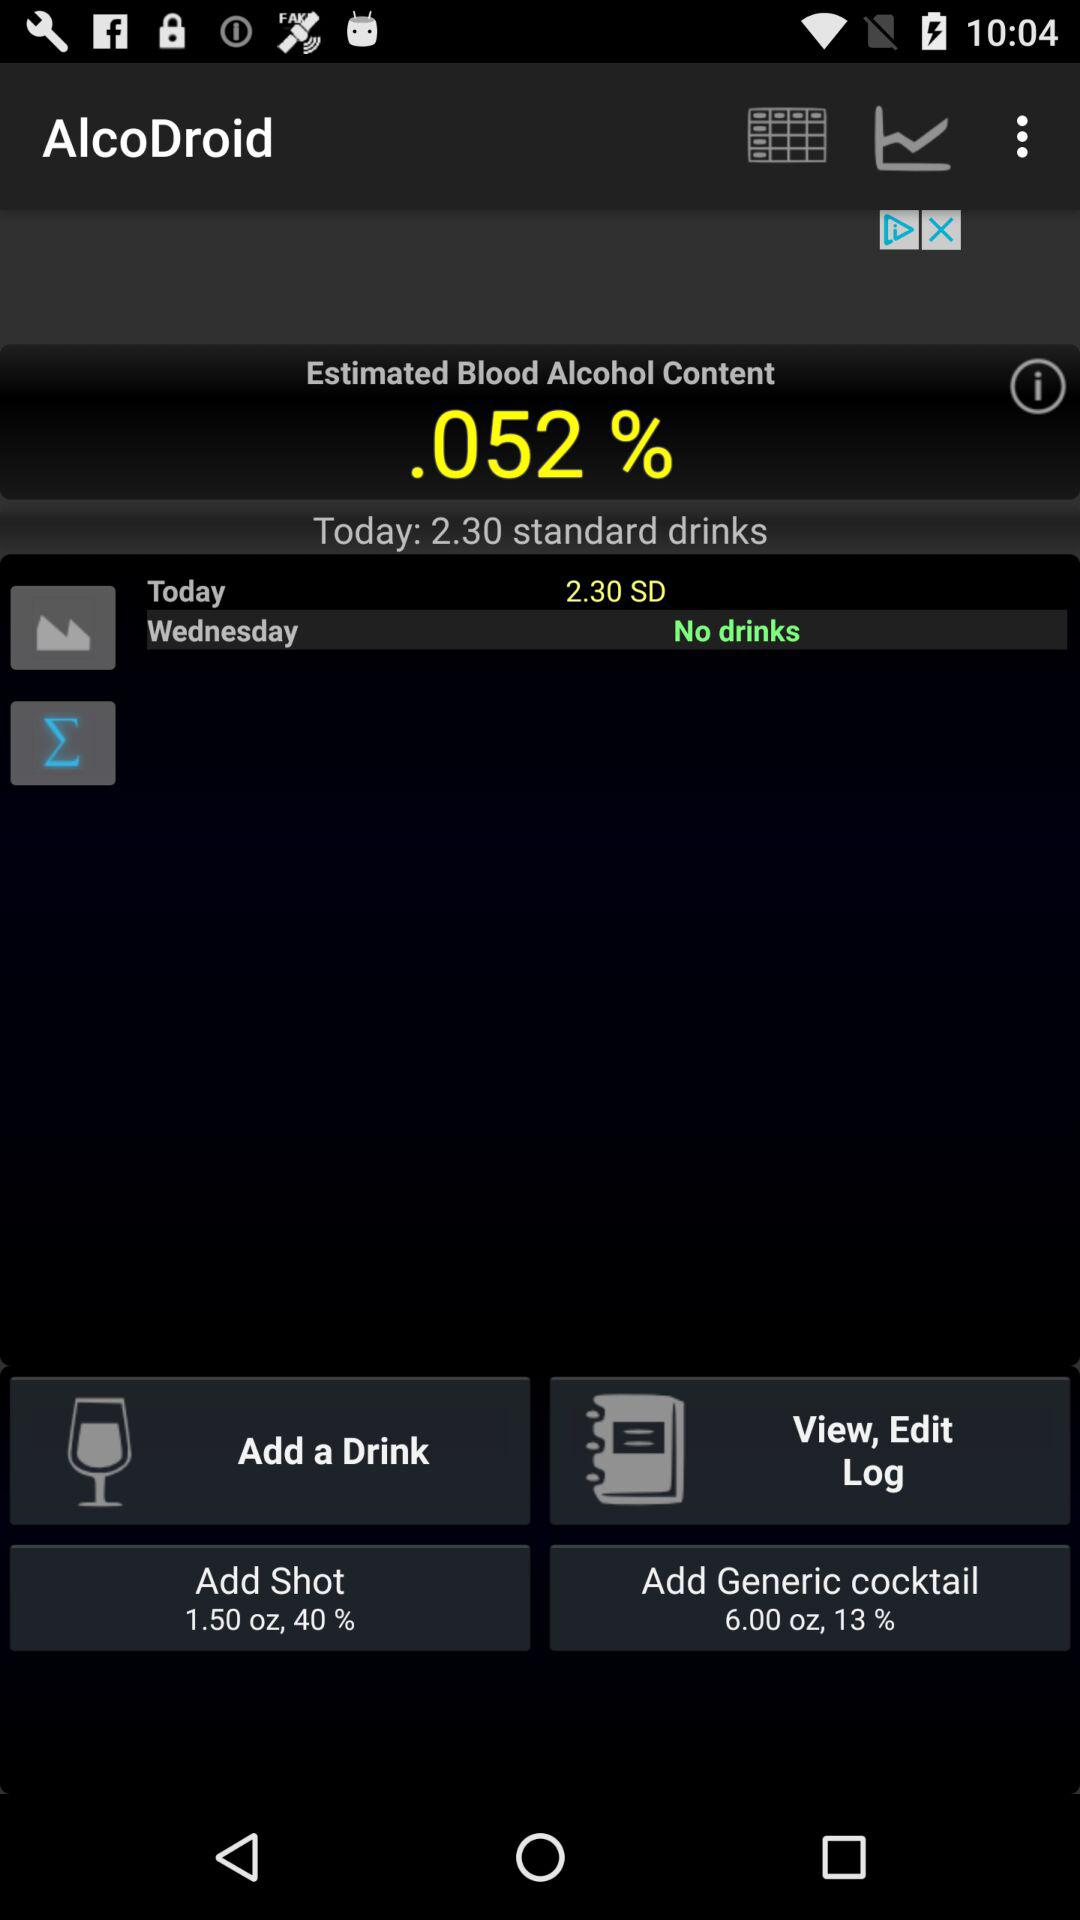What percentage of alcohol is present in the generic cocktail? The percentage of alcohol present in the generic cocktail is 13. 